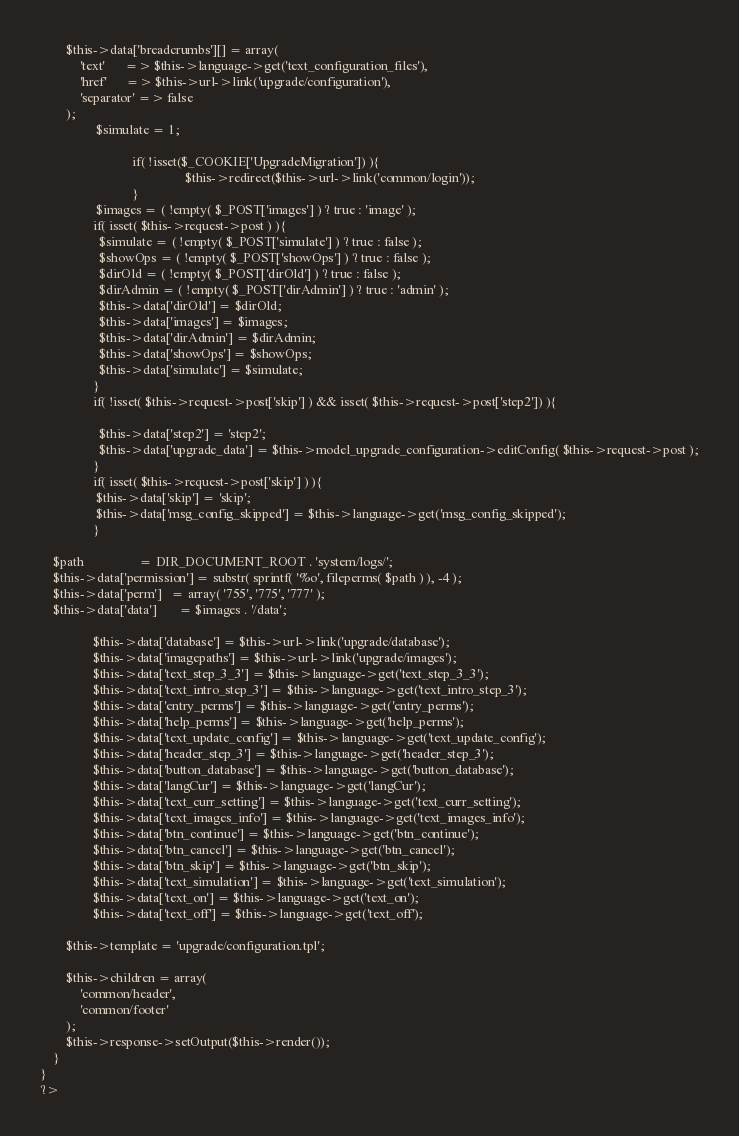<code> <loc_0><loc_0><loc_500><loc_500><_PHP_>		$this->data['breadcrumbs'][] = array(
			'text'      => $this->language->get('text_configuration_files'),
			'href'      => $this->url->link('upgrade/configuration'),
			'separator' => false
		);
                 $simulate = 1;

							if( !isset($_COOKIE['UpgradeMigration']) ){
											$this->redirect($this->url->link('common/login'));
							}
                 $images = ( !empty( $_POST['images'] ) ? true : 'image' );
                if( isset( $this->request->post ) ){
                  $simulate = ( !empty( $_POST['simulate'] ) ? true : false );
                  $showOps = ( !empty( $_POST['showOps'] ) ? true : false );
                  $dirOld = ( !empty( $_POST['dirOld'] ) ? true : false );
                  $dirAdmin = ( !empty( $_POST['dirAdmin'] ) ? true : 'admin' );
                  $this->data['dirOld'] = $dirOld;
                  $this->data['images'] = $images;
                  $this->data['dirAdmin'] = $dirAdmin;
                  $this->data['showOps'] = $showOps;
                  $this->data['simulate'] = $simulate;
                }
                if( !isset( $this->request->post['skip'] ) && isset( $this->request->post['step2']) ){

                  $this->data['step2'] = 'step2';
                  $this->data['upgrade_data'] = $this->model_upgrade_configuration->editConfig( $this->request->post );
                } 
                if( isset( $this->request->post['skip'] ) ){
                 $this->data['skip'] = 'skip';
                 $this->data['msg_config_skipped'] = $this->language->get('msg_config_skipped');
                }

	$path		          = DIR_DOCUMENT_ROOT . 'system/logs/';
	$this->data['permission'] = substr( sprintf( '%o', fileperms( $path ) ), -4 );
	$this->data['perm']	  = array( '755', '775', '777' );
	$this->data['data']       = $images . '/data';

                $this->data['database'] = $this->url->link('upgrade/database');
                $this->data['imagepaths'] = $this->url->link('upgrade/images');
                $this->data['text_step_3_3'] = $this->language->get('text_step_3_3');
                $this->data['text_intro_step_3'] = $this->language->get('text_intro_step_3');
                $this->data['entry_perms'] = $this->language->get('entry_perms');
                $this->data['help_perms'] = $this->language->get('help_perms');
                $this->data['text_update_config'] = $this->language->get('text_update_config');
                $this->data['header_step_3'] = $this->language->get('header_step_3');
                $this->data['button_database'] = $this->language->get('button_database');
                $this->data['langCur'] = $this->language->get('langCur');
                $this->data['text_curr_setting'] = $this->language->get('text_curr_setting');
                $this->data['text_images_info'] = $this->language->get('text_images_info');
                $this->data['btn_continue'] = $this->language->get('btn_continue');
                $this->data['btn_cancel'] = $this->language->get('btn_cancel');
                $this->data['btn_skip'] = $this->language->get('btn_skip');
                $this->data['text_simulation'] = $this->language->get('text_simulation');
                $this->data['text_on'] = $this->language->get('text_on');
                $this->data['text_off'] = $this->language->get('text_off');

		$this->template = 'upgrade/configuration.tpl';

		$this->children = array(
			'common/header',
			'common/footer'
		);
		$this->response->setOutput($this->render());
	}
}
?>
</code> 